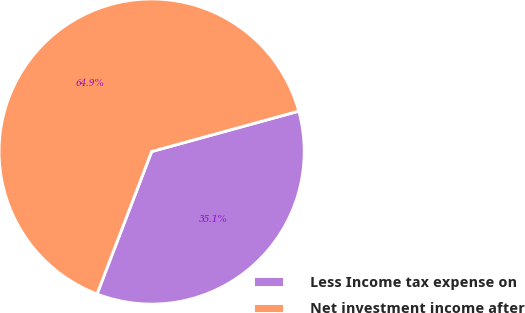<chart> <loc_0><loc_0><loc_500><loc_500><pie_chart><fcel>Less Income tax expense on<fcel>Net investment income after<nl><fcel>35.09%<fcel>64.91%<nl></chart> 